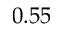<formula> <loc_0><loc_0><loc_500><loc_500>0 . 5 5</formula> 